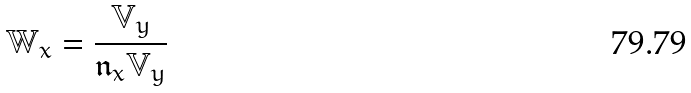<formula> <loc_0><loc_0><loc_500><loc_500>\mathbb { W } _ { x } = \frac { \mathbb { V } _ { y } } { \mathfrak { n } _ { x } \mathbb { V } _ { y } }</formula> 